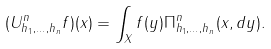Convert formula to latex. <formula><loc_0><loc_0><loc_500><loc_500>( U ^ { n } _ { h _ { 1 } , \dots , h _ { n } } f ) ( x ) = \int _ { X } f ( y ) \Pi ^ { n } _ { h _ { 1 } , \dots , h _ { n } } ( x , d y ) .</formula> 